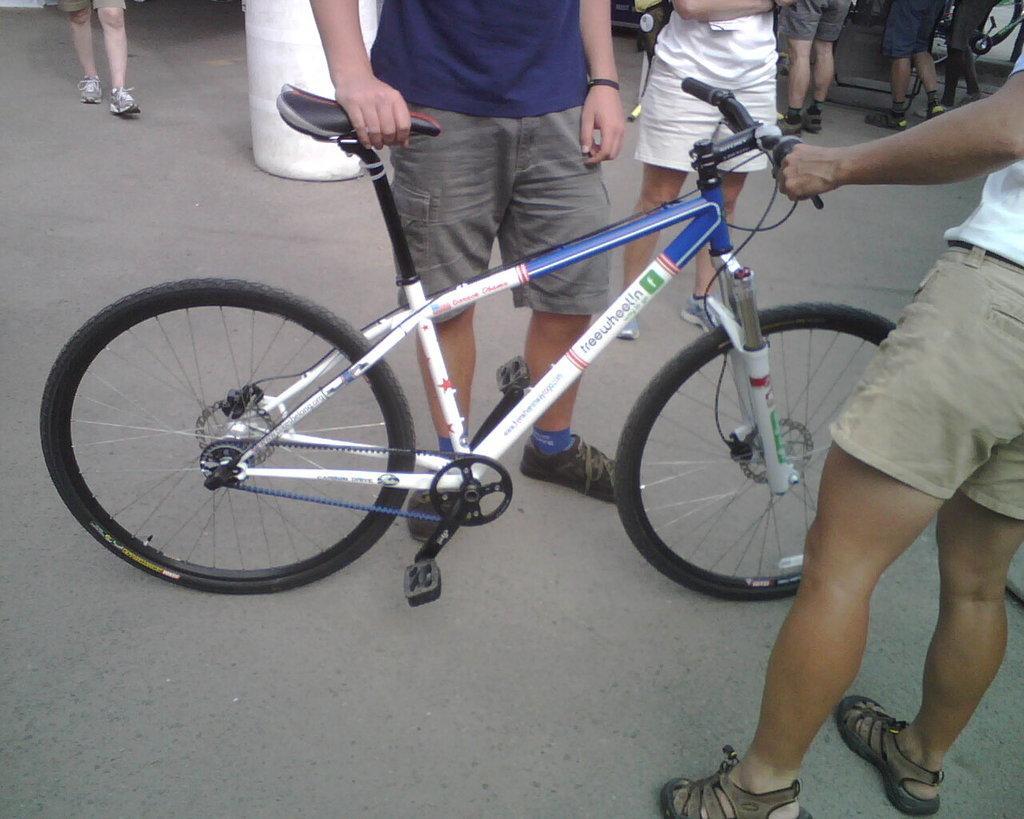In one or two sentences, can you explain what this image depicts? These two people are holding bicycles. Background there are people. 